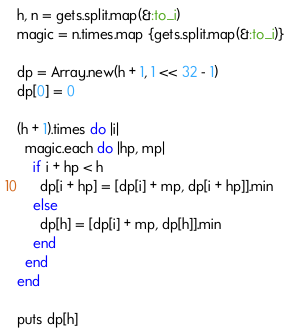Convert code to text. <code><loc_0><loc_0><loc_500><loc_500><_Ruby_>h, n = gets.split.map(&:to_i)
magic = n.times.map {gets.split.map(&:to_i)}

dp = Array.new(h + 1, 1 << 32 - 1)
dp[0] = 0

(h + 1).times do |i|
  magic.each do |hp, mp|
    if i + hp < h
      dp[i + hp] = [dp[i] + mp, dp[i + hp]].min
    else
      dp[h] = [dp[i] + mp, dp[h]].min
    end
  end
end

puts dp[h]</code> 